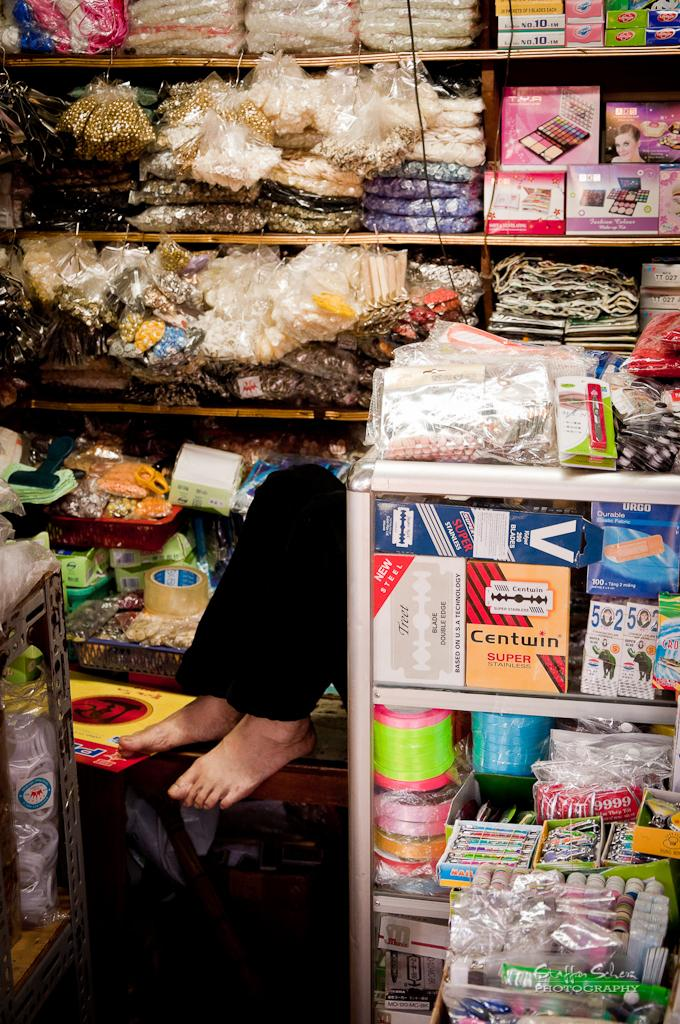What part of a person can be seen in the image? There are legs of a person visible in the image. What type of items are present in the image? There are boxes, packets, objects on racks, and objects on tables in the image. Can you describe the arrangement of the objects in the image? The objects are placed on racks and tables in the image. How many rings does the carpenter have on their fingers in the image? There is no carpenter or rings present in the image. 